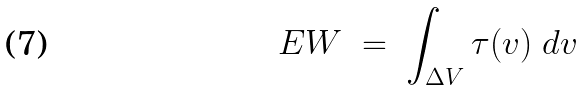Convert formula to latex. <formula><loc_0><loc_0><loc_500><loc_500>E W \ = \ \int _ { \Delta V } { \tau ( v ) \ d v }</formula> 